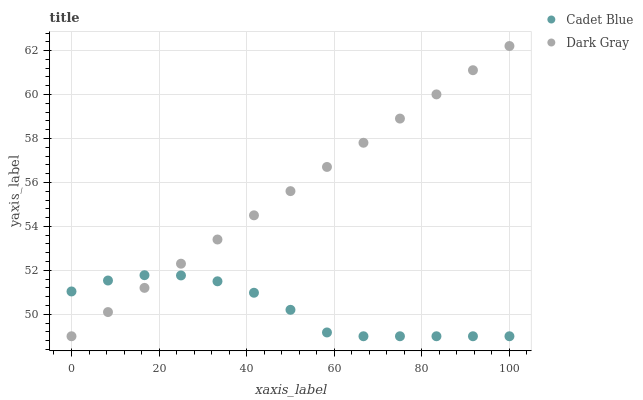Does Cadet Blue have the minimum area under the curve?
Answer yes or no. Yes. Does Dark Gray have the maximum area under the curve?
Answer yes or no. Yes. Does Cadet Blue have the maximum area under the curve?
Answer yes or no. No. Is Dark Gray the smoothest?
Answer yes or no. Yes. Is Cadet Blue the roughest?
Answer yes or no. Yes. Is Cadet Blue the smoothest?
Answer yes or no. No. Does Dark Gray have the lowest value?
Answer yes or no. Yes. Does Dark Gray have the highest value?
Answer yes or no. Yes. Does Cadet Blue have the highest value?
Answer yes or no. No. Does Dark Gray intersect Cadet Blue?
Answer yes or no. Yes. Is Dark Gray less than Cadet Blue?
Answer yes or no. No. Is Dark Gray greater than Cadet Blue?
Answer yes or no. No. 